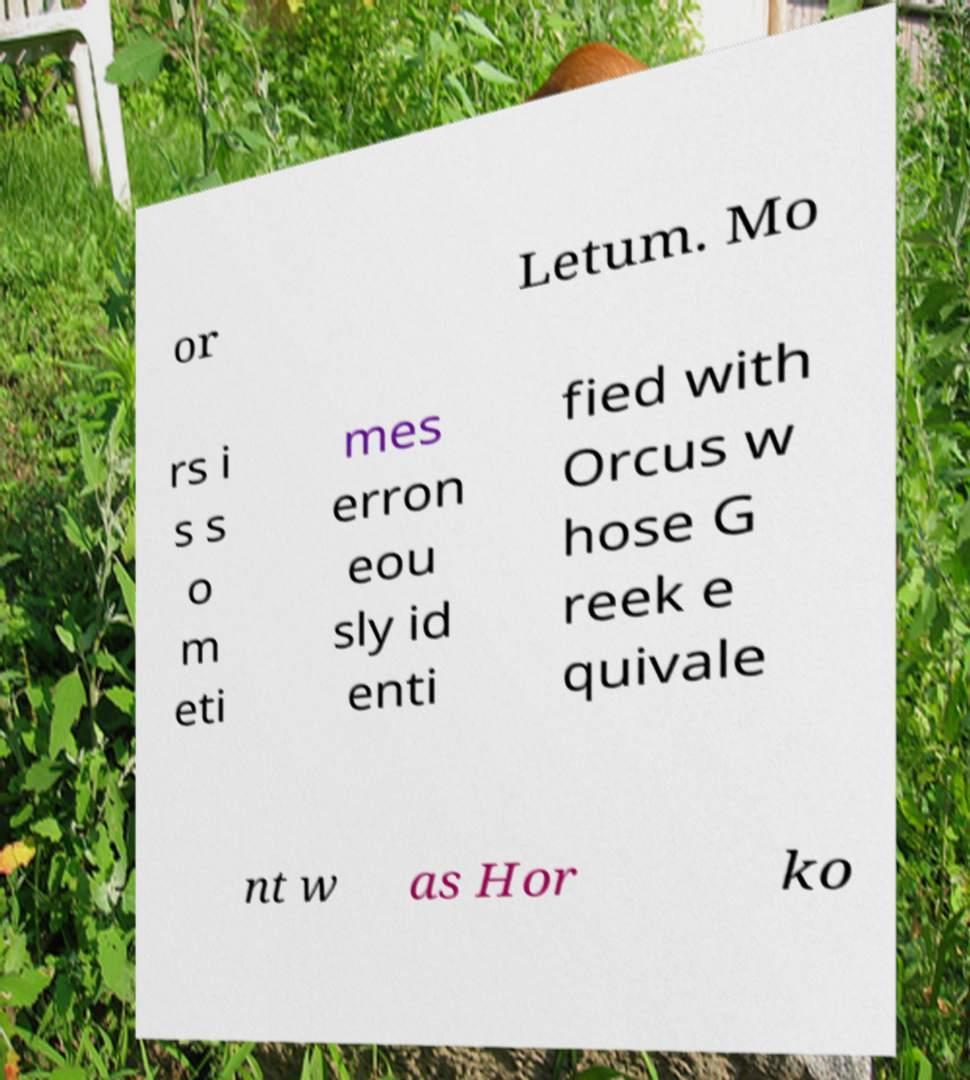I need the written content from this picture converted into text. Can you do that? or Letum. Mo rs i s s o m eti mes erron eou sly id enti fied with Orcus w hose G reek e quivale nt w as Hor ko 